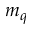<formula> <loc_0><loc_0><loc_500><loc_500>m _ { q }</formula> 